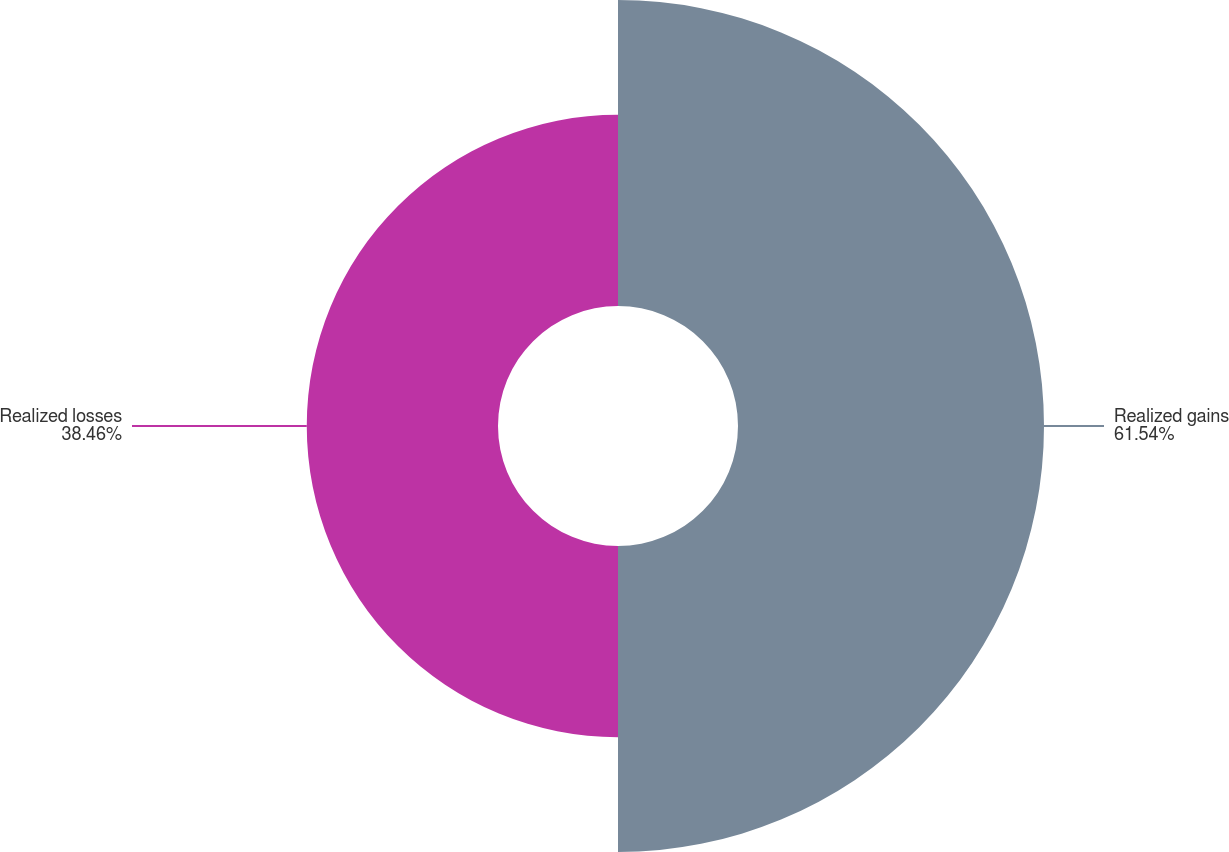Convert chart. <chart><loc_0><loc_0><loc_500><loc_500><pie_chart><fcel>Realized gains<fcel>Realized losses<nl><fcel>61.54%<fcel>38.46%<nl></chart> 